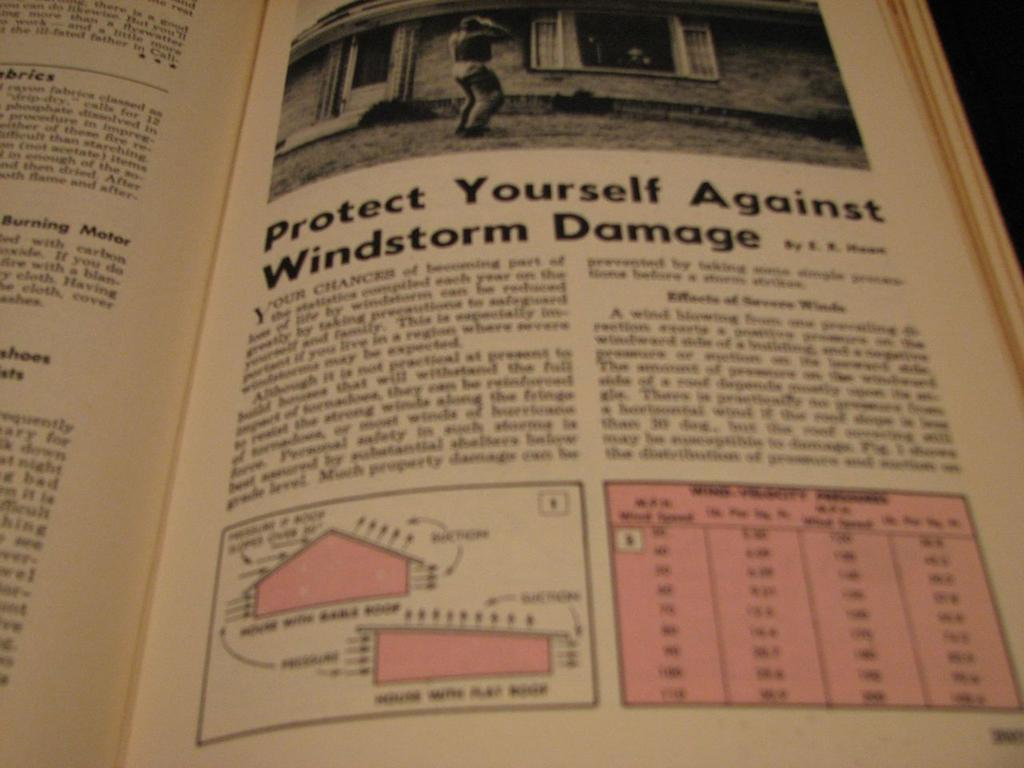<image>
Write a terse but informative summary of the picture. A chapter titled Protect yourself against windstorm damage 